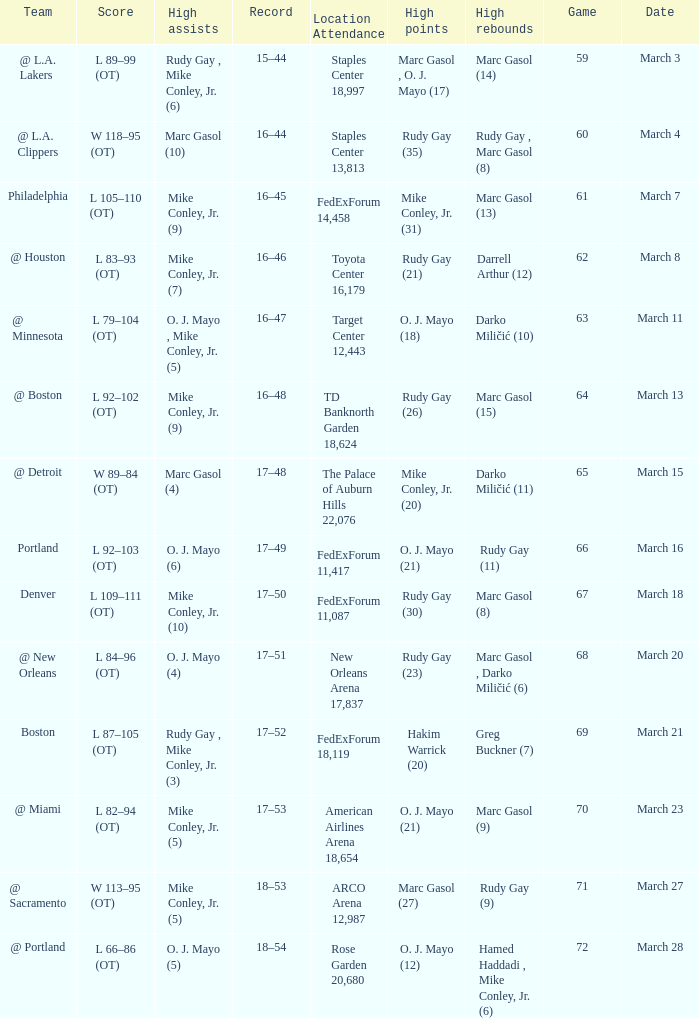What was the location and attendance for game 60? Staples Center 13,813. 